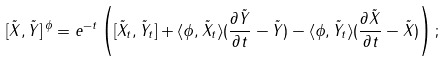Convert formula to latex. <formula><loc_0><loc_0><loc_500><loc_500>[ \tilde { X } , \tilde { Y } ] ^ { \, \phi } = e ^ { - t } \left ( [ \tilde { X } _ { t } , \tilde { Y } _ { t } ] + \langle \phi , \tilde { X } _ { t } \rangle ( \frac { \partial \tilde { Y } } { \partial t } - \tilde { Y } ) - \langle \phi , \tilde { Y } _ { t } \rangle ( \frac { \partial \tilde { X } } { \partial t } - \tilde { X } ) \right ) ;</formula> 